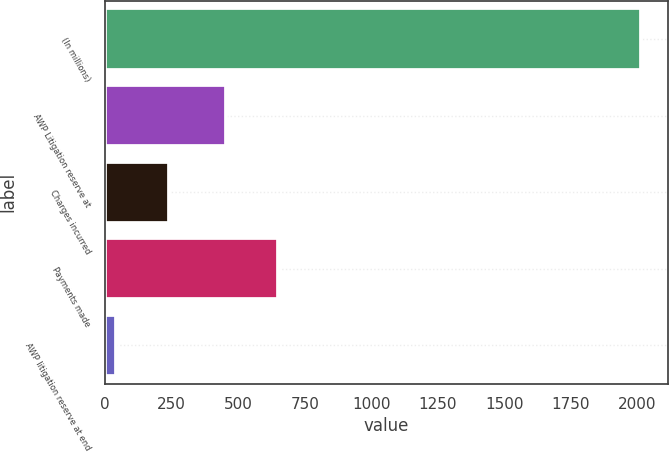Convert chart. <chart><loc_0><loc_0><loc_500><loc_500><bar_chart><fcel>(In millions)<fcel>AWP Litigation reserve at<fcel>Charges incurred<fcel>Payments made<fcel>AWP litigation reserve at end<nl><fcel>2013<fcel>453<fcel>239.1<fcel>650.1<fcel>42<nl></chart> 